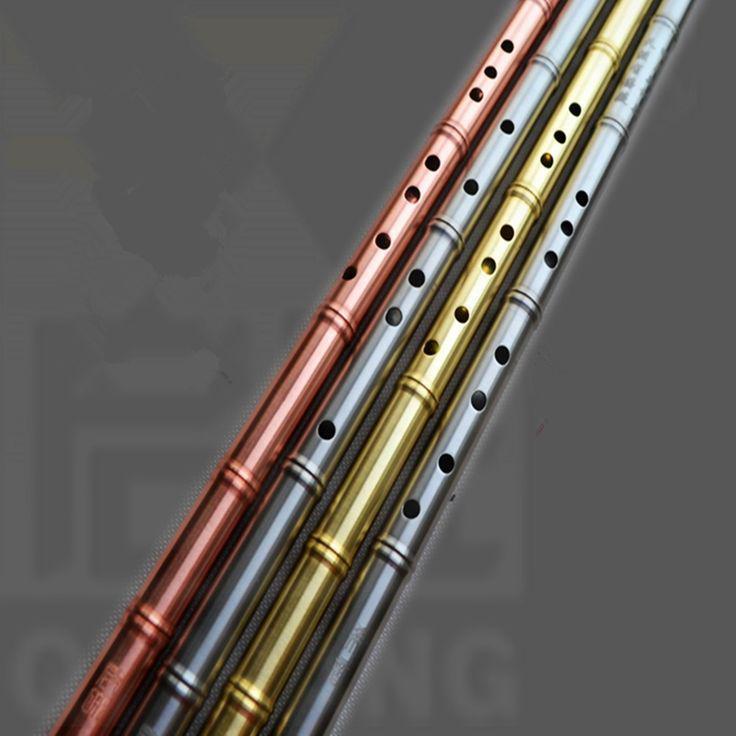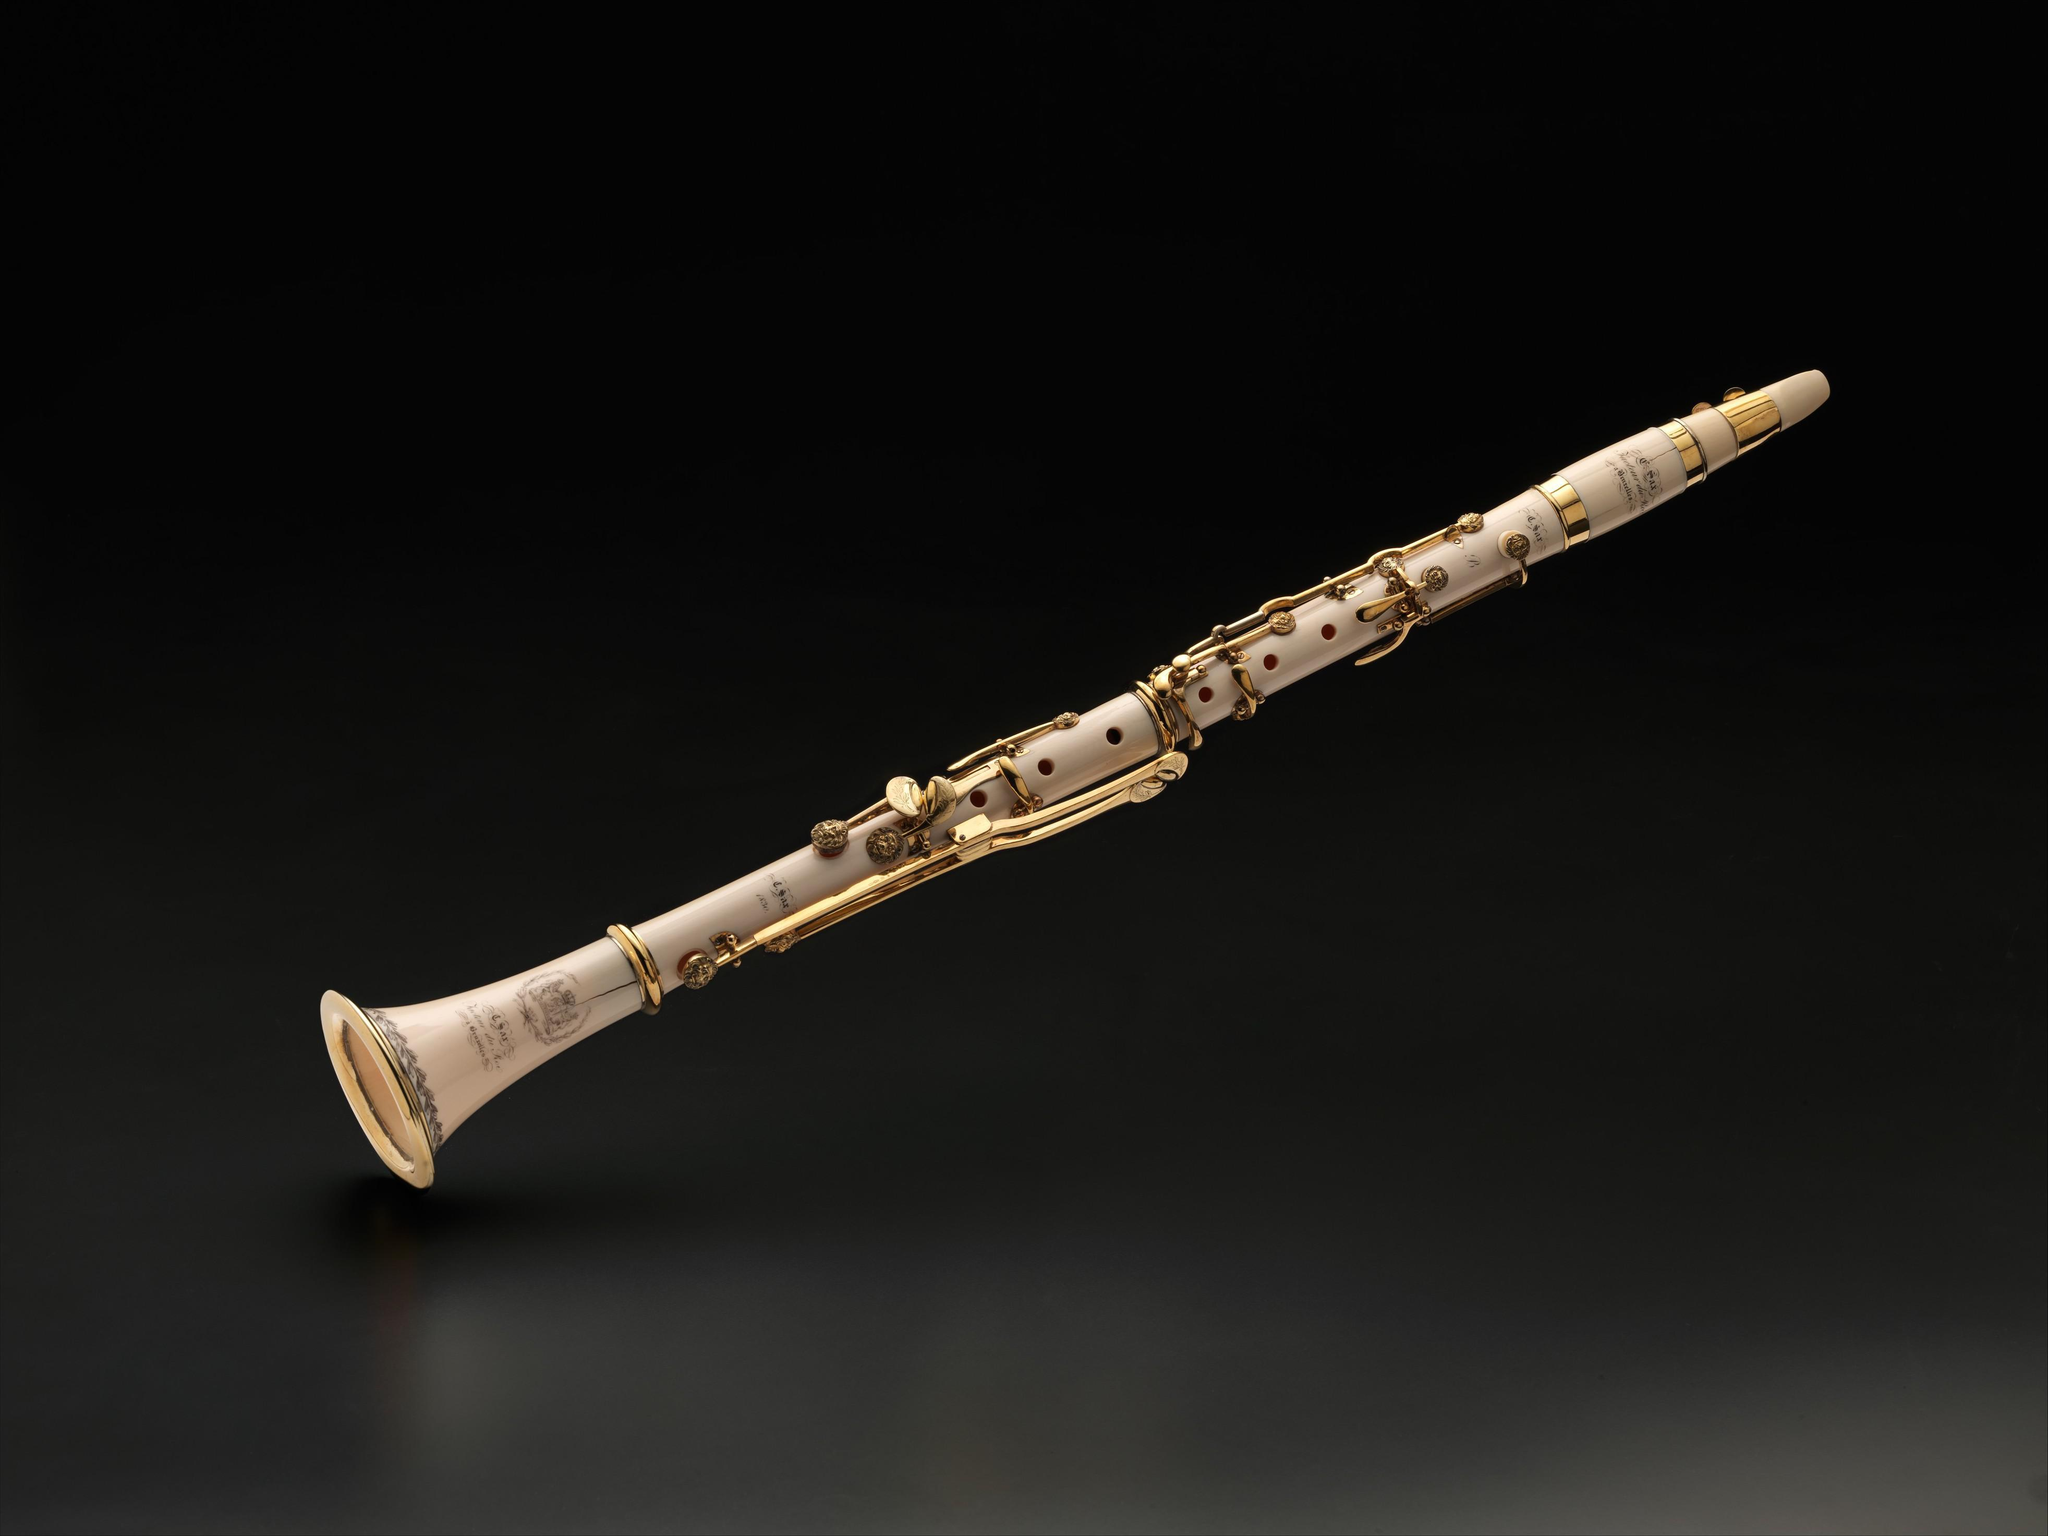The first image is the image on the left, the second image is the image on the right. Evaluate the accuracy of this statement regarding the images: "Two light colored flutes sit side by side.". Is it true? Answer yes or no. No. The first image is the image on the left, the second image is the image on the right. For the images shown, is this caption "One image shows a single flute displayed diagonally, and the other image shows at least two flutes displayed right next to each other diagonally." true? Answer yes or no. Yes. 